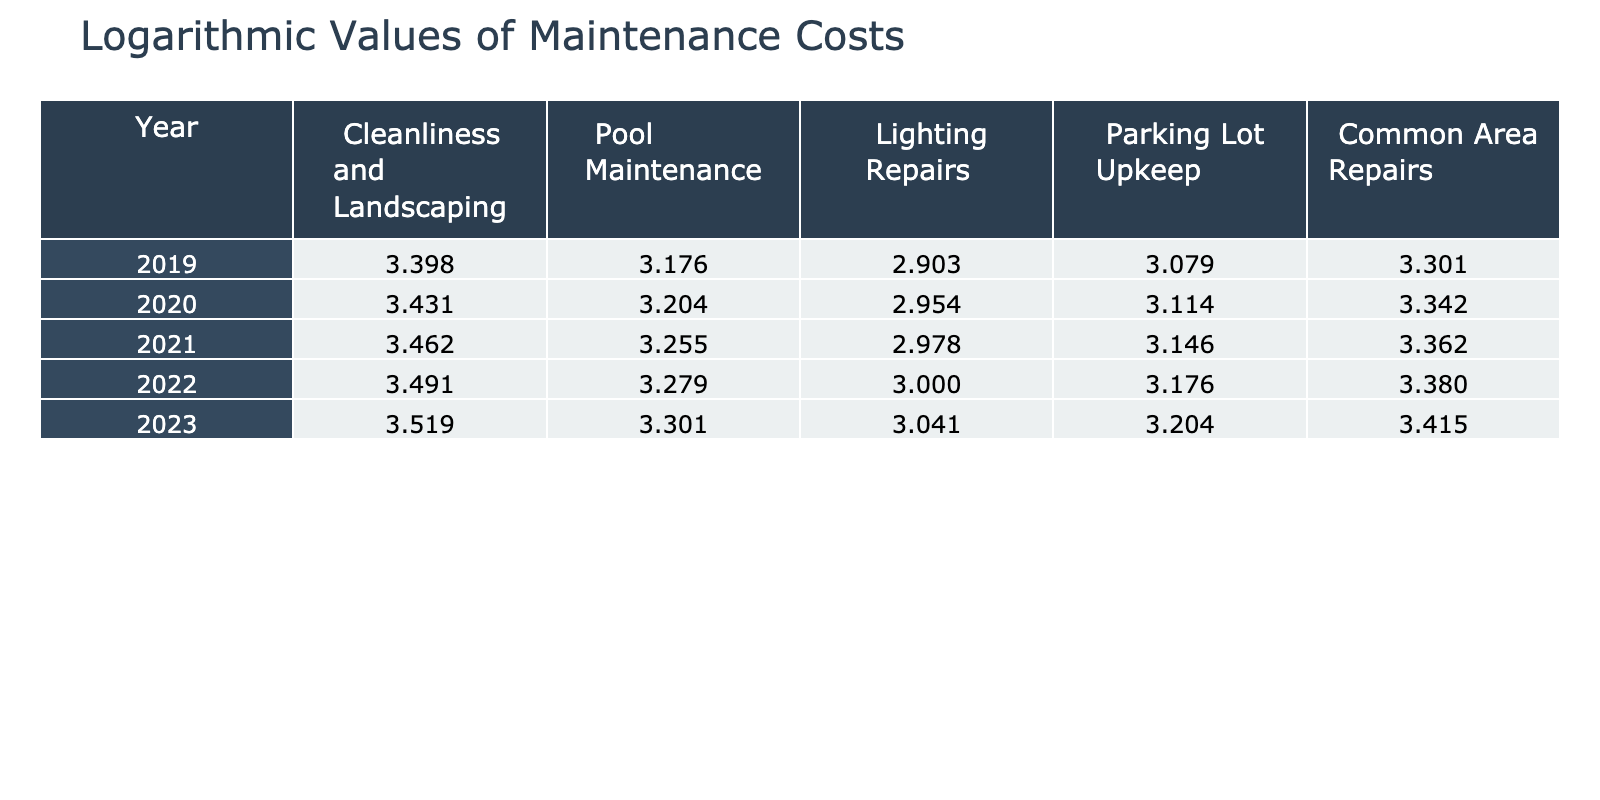What was the cleanliness and landscaping cost in 2023? The table indicates that the cleanliness and landscaping cost for the year 2023 is 3.319 (logarithmic value).
Answer: 3.319 What was the highest lighting repairs cost recorded over the five years? By looking through the table, the highest value in the Lighting Repairs column is for the year 2023, which is 3.041 (logarithmic value).
Answer: 3.041 Was the pool maintenance cost in 2021 higher than that in 2020? Comparing the pool maintenance costs in the table for 2021 (2.255) and 2020 (2.204), we find 2.255 > 2.204, confirming it was indeed higher.
Answer: Yes What is the total maintenance cost for common area repairs in 2022 compared to 2019? The common area repairs cost for 2022 is 3.380, and for 2019, it is 3.301. The difference is calculated as 3.380 - 3.301 = 0.079.
Answer: 0.079 What year had the least increase in cleanliness and landscaping costs compared to the prior year? The increases in cleanliness and landscaping costs are as follows: 2019-2020 (200), 2020-2021 (200), 2021-2022 (200), 2022-2023 (200). All years show the same increase, making it equal for all.
Answer: All years have the same increase 